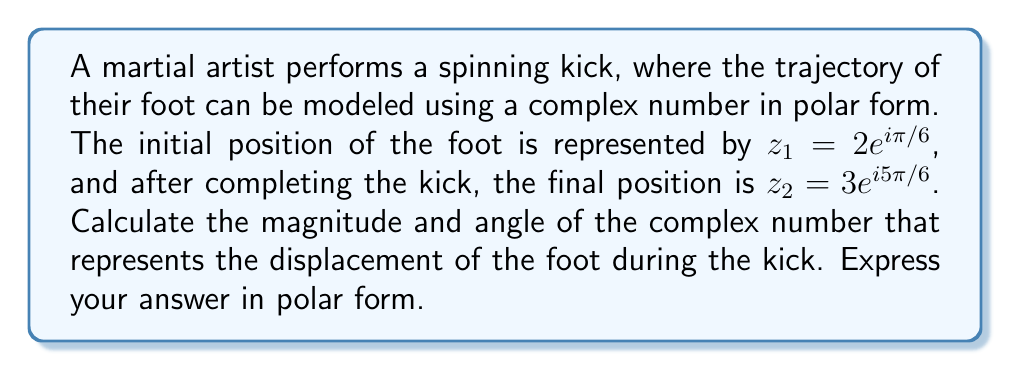Could you help me with this problem? To solve this problem, we need to follow these steps:

1) The displacement is represented by the difference between the final and initial positions:
   $z = z_2 - z_1$

2) Let's expand this using the given polar forms:
   $z = 3e^{i5\pi/6} - 2e^{i\pi/6}$

3) To subtract these complex numbers, we need to convert them to rectangular form:
   $z_1 = 2e^{i\pi/6} = 2(\cos(\pi/6) + i\sin(\pi/6)) = 2(\sqrt{3}/2 + i/2) = \sqrt{3} + i$
   $z_2 = 3e^{i5\pi/6} = 3(\cos(5\pi/6) + i\sin(5\pi/6)) = 3(-\sqrt{3}/2 + i/2) = -3\sqrt{3}/2 + 3i/2$

4) Now we can subtract:
   $z = (-3\sqrt{3}/2 + 3i/2) - (\sqrt{3} + i) = -3\sqrt{3}/2 - \sqrt{3} + 3i/2 - i = -5\sqrt{3}/2 + i/2$

5) To convert this back to polar form, we need to calculate the magnitude and angle:

   Magnitude: $r = \sqrt{(-5\sqrt{3}/2)^2 + (1/2)^2} = \sqrt{75/4 + 1/4} = \sqrt{19}$

   Angle: $\theta = \arctan(\frac{1/2}{-5\sqrt{3}/2}) = \arctan(-\frac{1}{5\sqrt{3}})$

   However, since the real part is negative and the imaginary part is positive, we need to add $\pi$ to this result:

   $\theta = \arctan(-\frac{1}{5\sqrt{3}}) + \pi \approx 2.8198$ radians

6) Therefore, the displacement in polar form is $\sqrt{19}e^{i2.8198}$
Answer: $\sqrt{19}e^{i2.8198}$ 